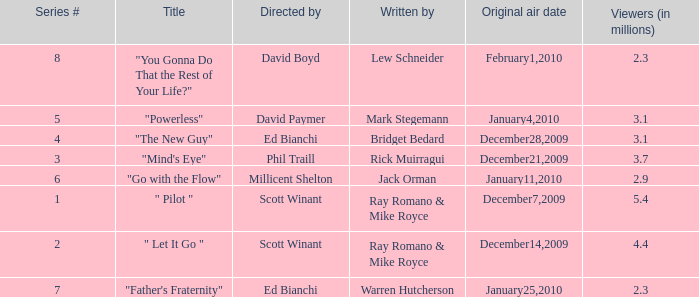What is the episode number of  "you gonna do that the rest of your life?" 8.0. 